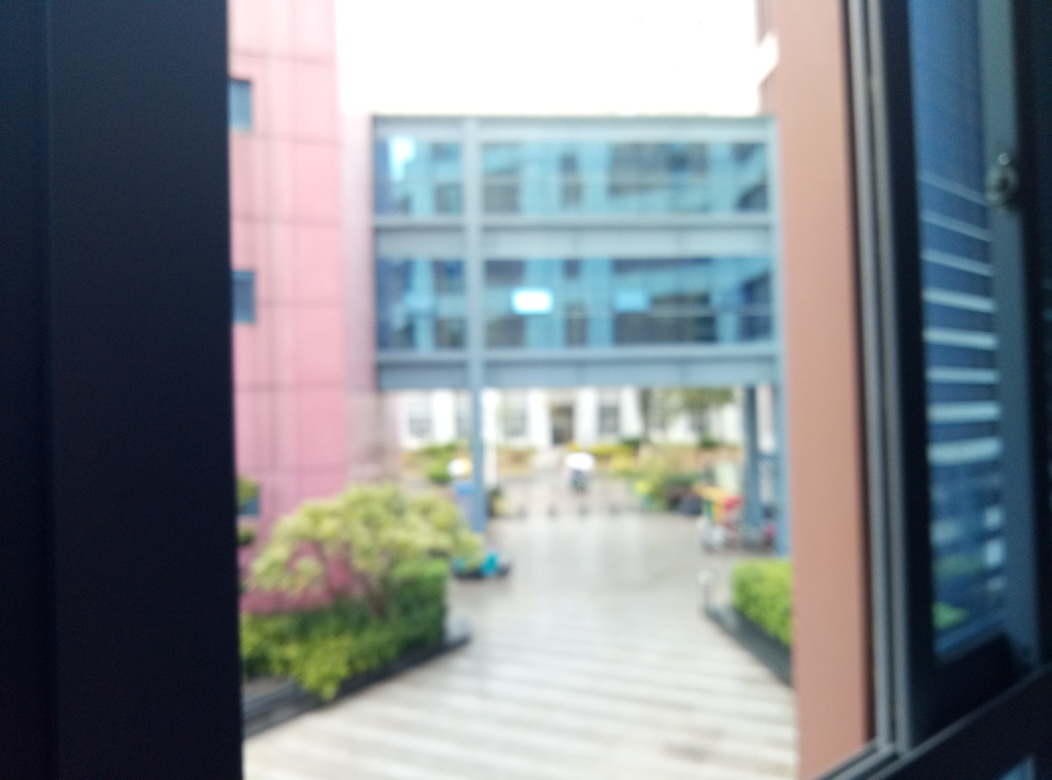Can you tell me what the weather was like based on this image? The image appears to be taken on a day with ample natural light suggesting that the weather was clear or partly cloudy. However, due to the overexposed sky and the lack of image clarity, it's difficult to provide a precise description of the weather conditions. Could the overexposure be a result of a technical mishap or intentional effect? Overexposure can occur due to a technical mishap where the camera settings are not adjusted to match the lighting conditions, resulting in too much light being captured. It could also be an intentional decision to create a specific aesthetic. In this case, without additional context it's challenging to determine the exact cause of the overexposure. 